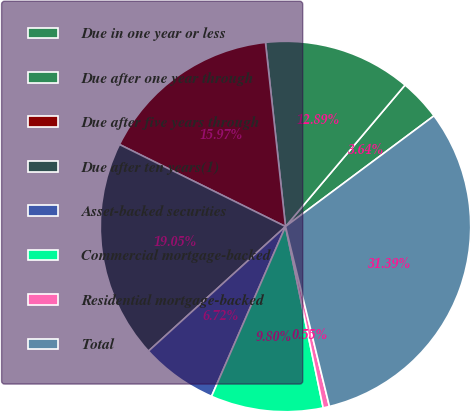Convert chart. <chart><loc_0><loc_0><loc_500><loc_500><pie_chart><fcel>Due in one year or less<fcel>Due after one year through<fcel>Due after five years through<fcel>Due after ten years(1)<fcel>Asset-backed securities<fcel>Commercial mortgage-backed<fcel>Residential mortgage-backed<fcel>Total<nl><fcel>3.64%<fcel>12.89%<fcel>15.97%<fcel>19.05%<fcel>6.72%<fcel>9.8%<fcel>0.55%<fcel>31.39%<nl></chart> 